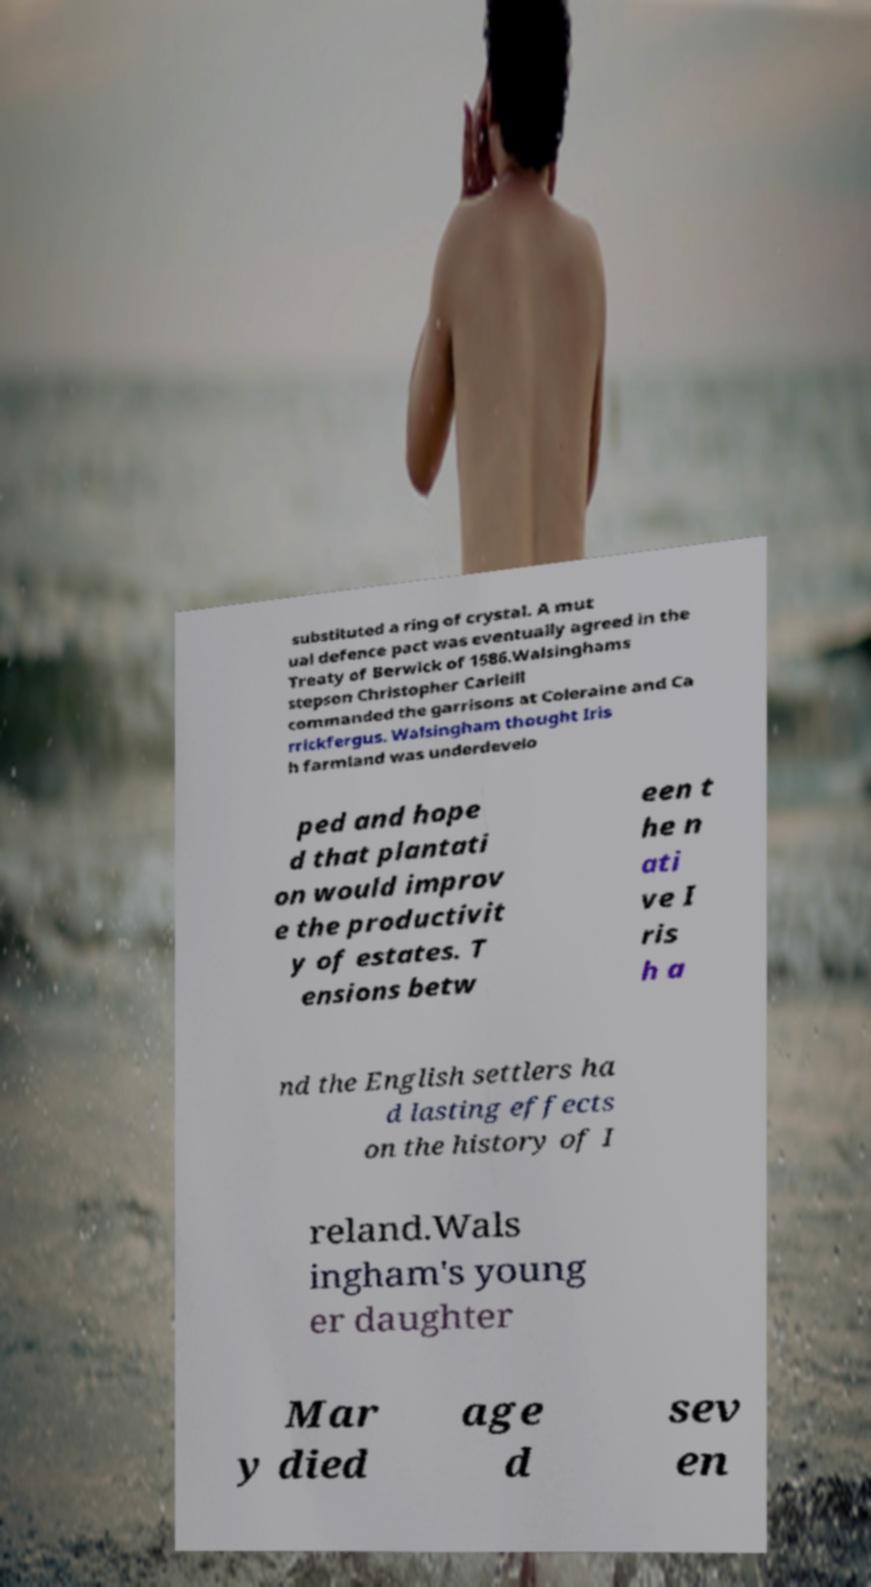I need the written content from this picture converted into text. Can you do that? substituted a ring of crystal. A mut ual defence pact was eventually agreed in the Treaty of Berwick of 1586.Walsinghams stepson Christopher Carleill commanded the garrisons at Coleraine and Ca rrickfergus. Walsingham thought Iris h farmland was underdevelo ped and hope d that plantati on would improv e the productivit y of estates. T ensions betw een t he n ati ve I ris h a nd the English settlers ha d lasting effects on the history of I reland.Wals ingham's young er daughter Mar y died age d sev en 